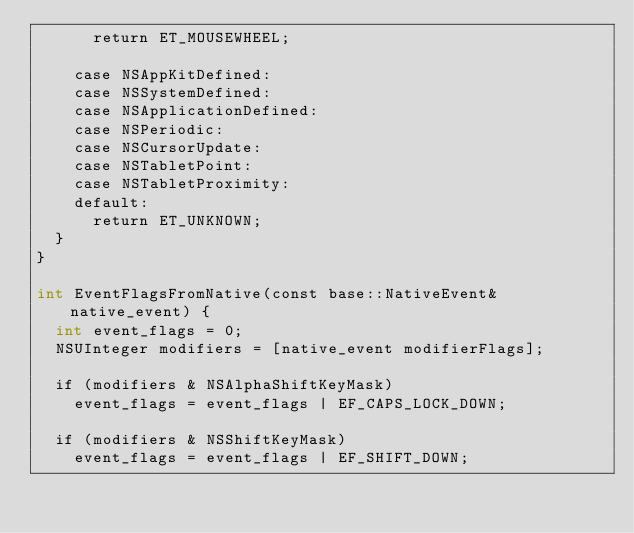Convert code to text. <code><loc_0><loc_0><loc_500><loc_500><_ObjectiveC_>      return ET_MOUSEWHEEL;

    case NSAppKitDefined:
    case NSSystemDefined:
    case NSApplicationDefined:
    case NSPeriodic:
    case NSCursorUpdate:
    case NSTabletPoint:
    case NSTabletProximity:
    default:
      return ET_UNKNOWN;
  }
}

int EventFlagsFromNative(const base::NativeEvent& native_event) {
  int event_flags = 0;
  NSUInteger modifiers = [native_event modifierFlags];

  if (modifiers & NSAlphaShiftKeyMask)
    event_flags = event_flags | EF_CAPS_LOCK_DOWN;

  if (modifiers & NSShiftKeyMask)
    event_flags = event_flags | EF_SHIFT_DOWN;
</code> 